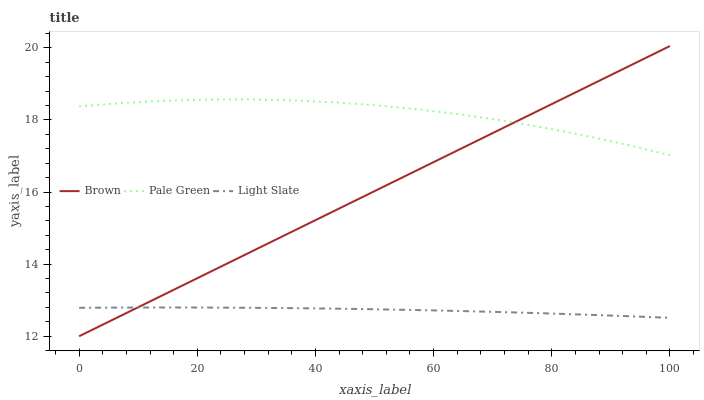Does Light Slate have the minimum area under the curve?
Answer yes or no. Yes. Does Pale Green have the maximum area under the curve?
Answer yes or no. Yes. Does Brown have the minimum area under the curve?
Answer yes or no. No. Does Brown have the maximum area under the curve?
Answer yes or no. No. Is Brown the smoothest?
Answer yes or no. Yes. Is Pale Green the roughest?
Answer yes or no. Yes. Is Pale Green the smoothest?
Answer yes or no. No. Is Brown the roughest?
Answer yes or no. No. Does Brown have the lowest value?
Answer yes or no. Yes. Does Pale Green have the lowest value?
Answer yes or no. No. Does Brown have the highest value?
Answer yes or no. Yes. Does Pale Green have the highest value?
Answer yes or no. No. Is Light Slate less than Pale Green?
Answer yes or no. Yes. Is Pale Green greater than Light Slate?
Answer yes or no. Yes. Does Light Slate intersect Brown?
Answer yes or no. Yes. Is Light Slate less than Brown?
Answer yes or no. No. Is Light Slate greater than Brown?
Answer yes or no. No. Does Light Slate intersect Pale Green?
Answer yes or no. No. 